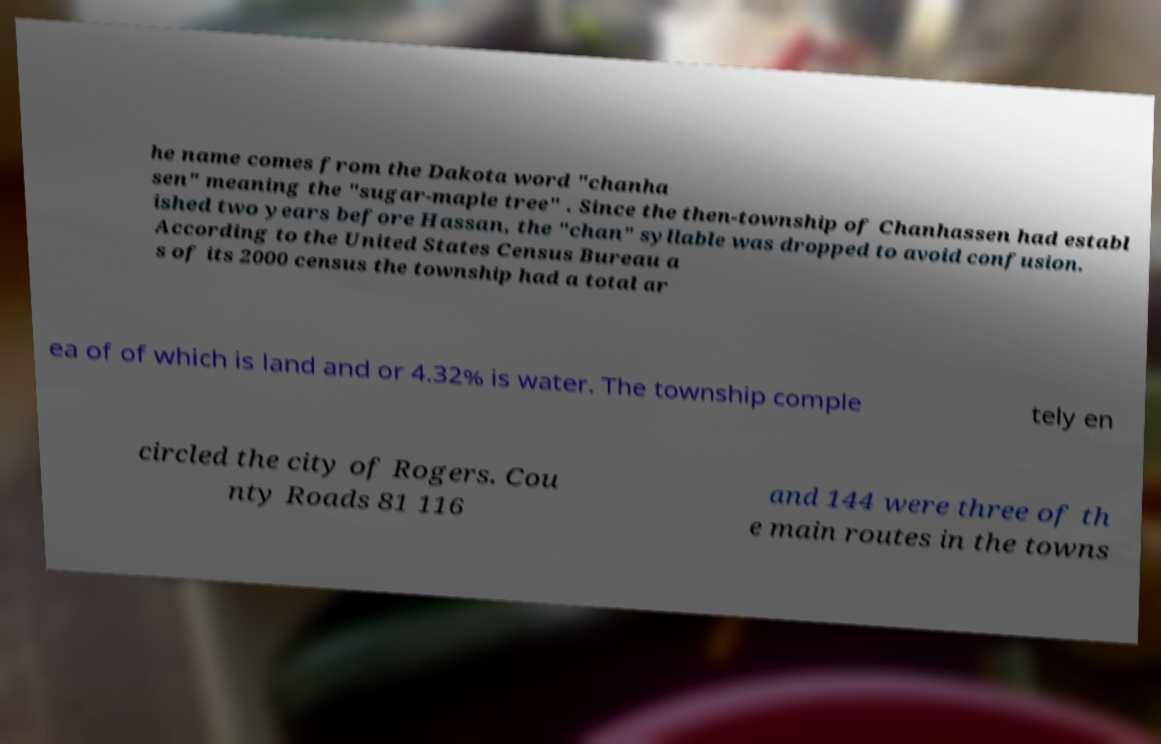For documentation purposes, I need the text within this image transcribed. Could you provide that? he name comes from the Dakota word "chanha sen" meaning the "sugar-maple tree" . Since the then-township of Chanhassen had establ ished two years before Hassan, the "chan" syllable was dropped to avoid confusion. According to the United States Census Bureau a s of its 2000 census the township had a total ar ea of of which is land and or 4.32% is water. The township comple tely en circled the city of Rogers. Cou nty Roads 81 116 and 144 were three of th e main routes in the towns 